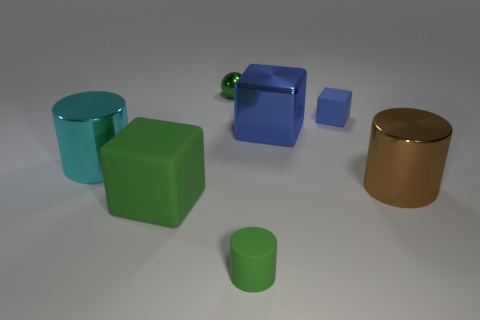What number of yellow things are tiny matte blocks or big matte objects?
Offer a very short reply. 0. There is a big metal object that is on the left side of the large green matte cube; is it the same color as the large metallic block?
Ensure brevity in your answer.  No. What is the shape of the large cyan object that is the same material as the big brown thing?
Provide a succinct answer. Cylinder. There is a tiny object that is on the left side of the tiny blue cube and on the right side of the small green shiny sphere; what color is it?
Keep it short and to the point. Green. How big is the metallic cylinder to the right of the tiny green sphere on the left side of the big brown metal cylinder?
Your answer should be compact. Large. Are there any small spheres of the same color as the matte cylinder?
Ensure brevity in your answer.  Yes. Are there the same number of big rubber cubes that are behind the large blue metal block and big blue cubes?
Offer a terse response. No. What number of large metal cylinders are there?
Offer a very short reply. 2. There is a metal object that is on the left side of the small green rubber object and in front of the tiny blue thing; what is its shape?
Offer a very short reply. Cylinder. Is the color of the big cylinder left of the brown thing the same as the cylinder right of the small cylinder?
Provide a succinct answer. No. 